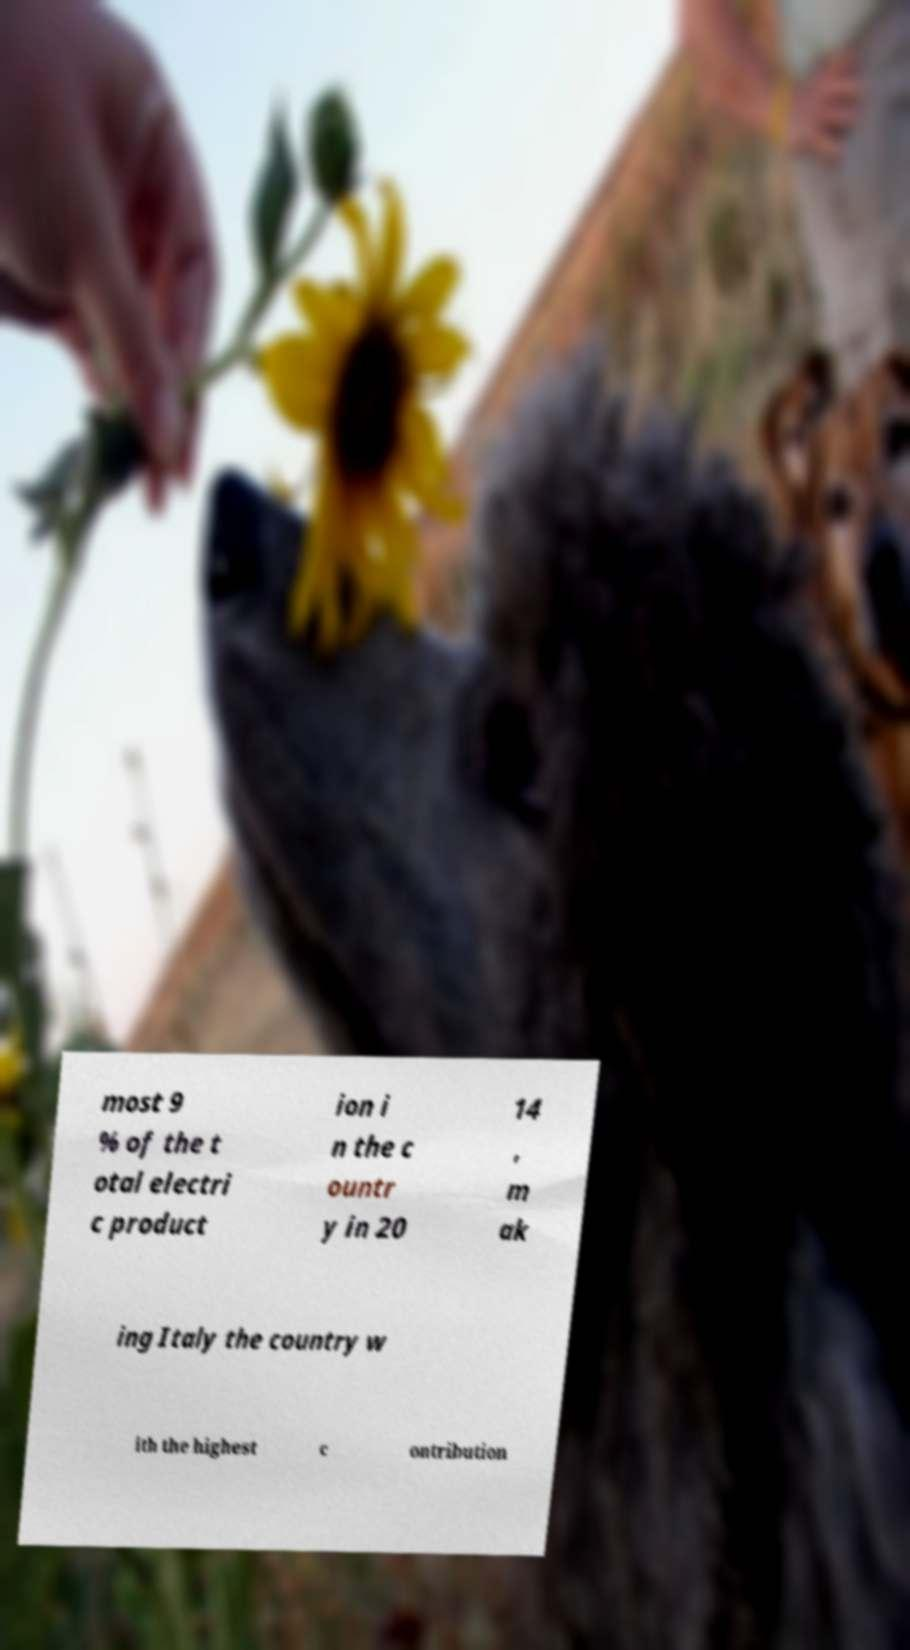Please identify and transcribe the text found in this image. most 9 % of the t otal electri c product ion i n the c ountr y in 20 14 , m ak ing Italy the country w ith the highest c ontribution 